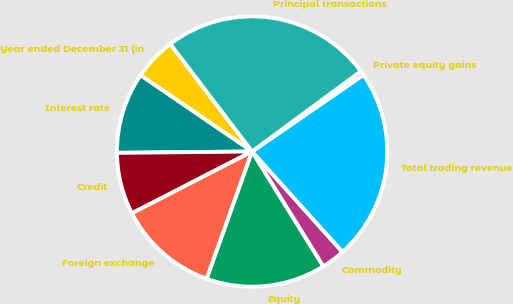<chart> <loc_0><loc_0><loc_500><loc_500><pie_chart><fcel>Year ended December 31 (in<fcel>Interest rate<fcel>Credit<fcel>Foreign exchange<fcel>Equity<fcel>Commodity<fcel>Total trading revenue<fcel>Private equity gains<fcel>Principal transactions<nl><fcel>5.11%<fcel>9.7%<fcel>7.4%<fcel>11.99%<fcel>14.29%<fcel>2.82%<fcel>22.94%<fcel>0.52%<fcel>25.23%<nl></chart> 